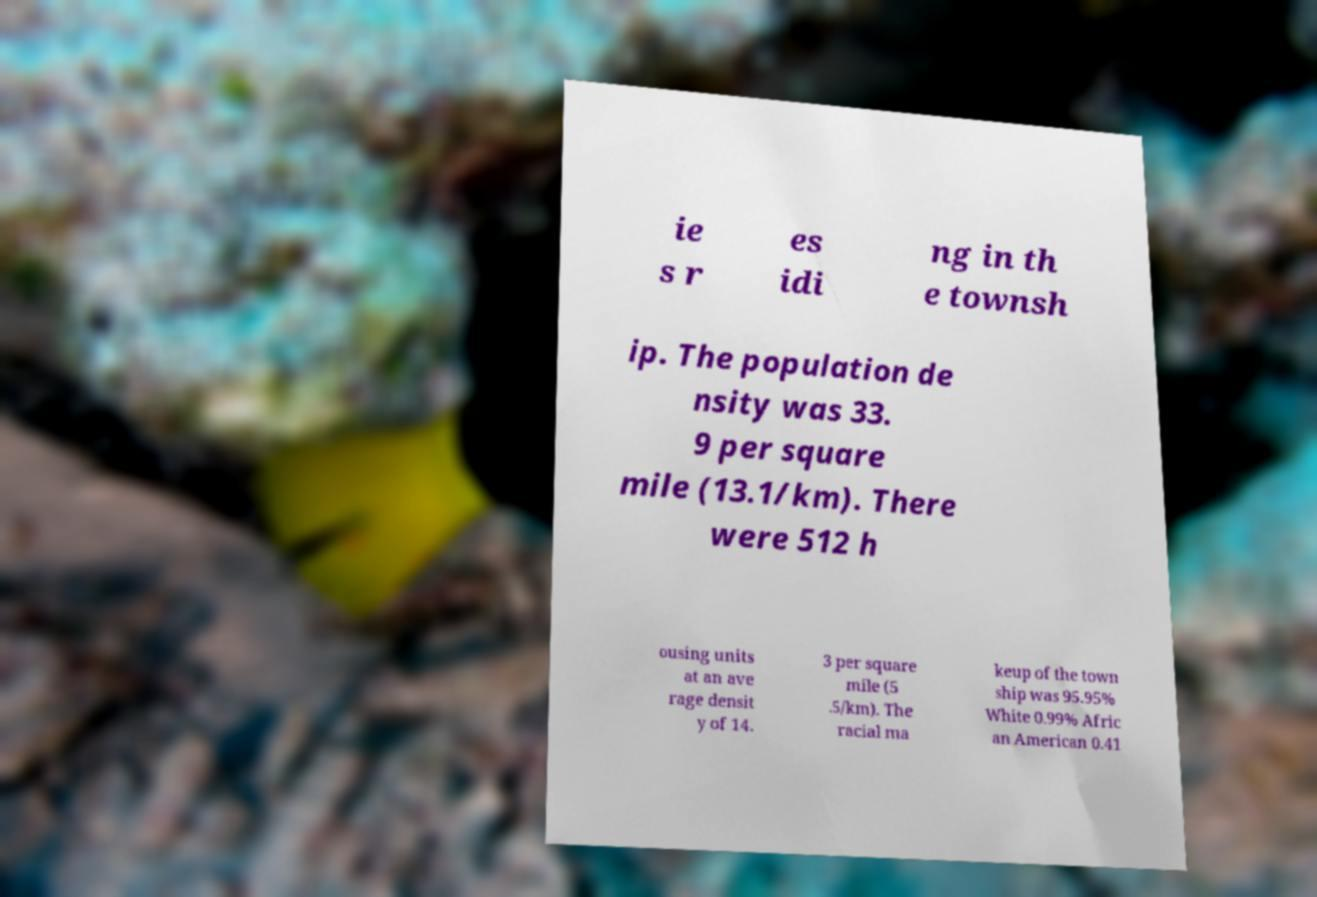Could you assist in decoding the text presented in this image and type it out clearly? ie s r es idi ng in th e townsh ip. The population de nsity was 33. 9 per square mile (13.1/km). There were 512 h ousing units at an ave rage densit y of 14. 3 per square mile (5 .5/km). The racial ma keup of the town ship was 95.95% White 0.99% Afric an American 0.41 